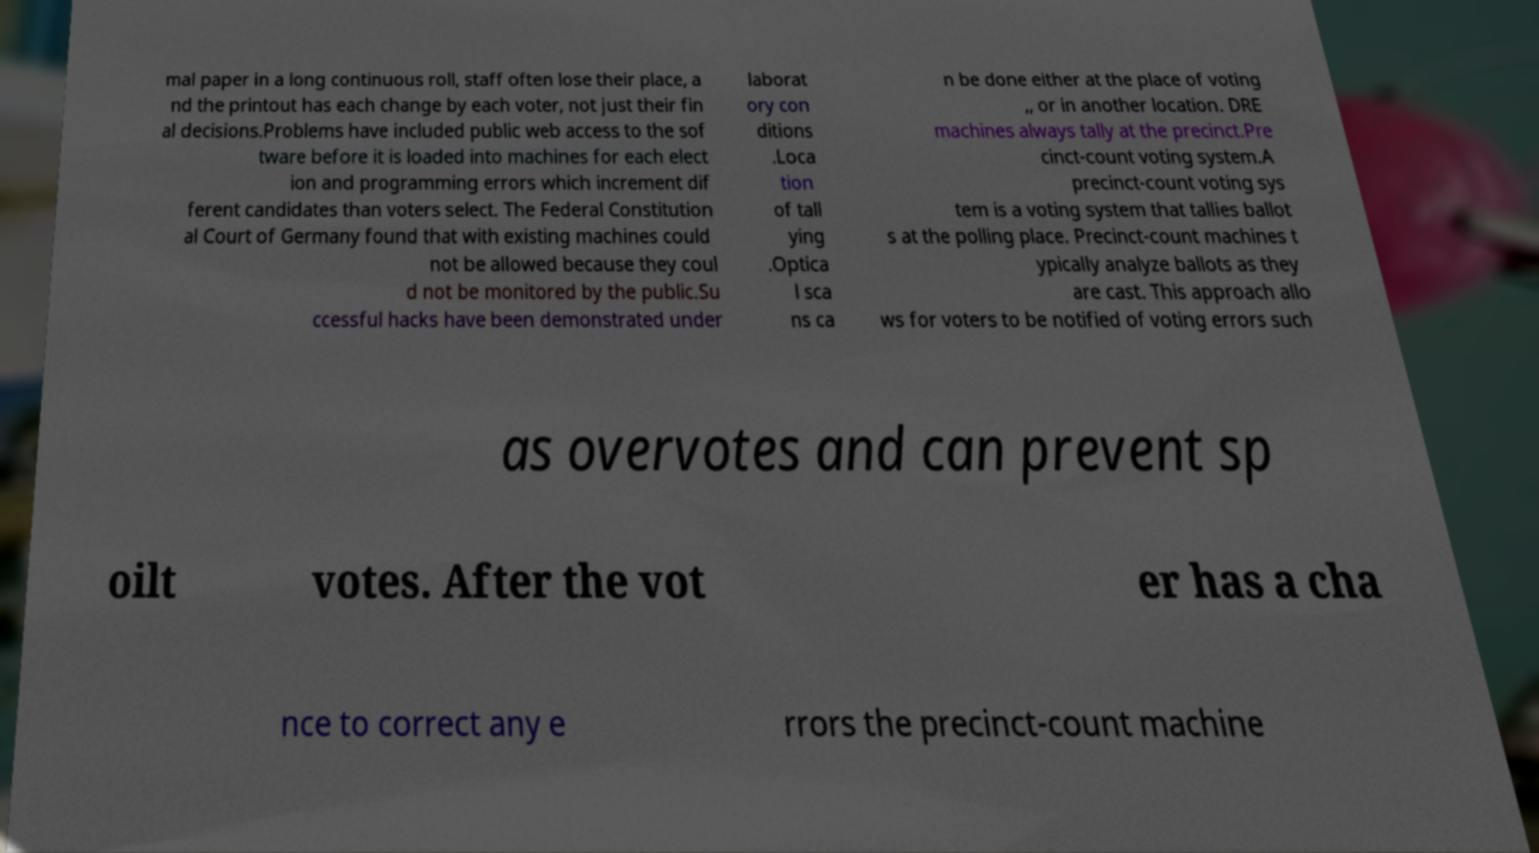Can you accurately transcribe the text from the provided image for me? mal paper in a long continuous roll, staff often lose their place, a nd the printout has each change by each voter, not just their fin al decisions.Problems have included public web access to the sof tware before it is loaded into machines for each elect ion and programming errors which increment dif ferent candidates than voters select. The Federal Constitution al Court of Germany found that with existing machines could not be allowed because they coul d not be monitored by the public.Su ccessful hacks have been demonstrated under laborat ory con ditions .Loca tion of tall ying .Optica l sca ns ca n be done either at the place of voting ,, or in another location. DRE machines always tally at the precinct.Pre cinct-count voting system.A precinct-count voting sys tem is a voting system that tallies ballot s at the polling place. Precinct-count machines t ypically analyze ballots as they are cast. This approach allo ws for voters to be notified of voting errors such as overvotes and can prevent sp oilt votes. After the vot er has a cha nce to correct any e rrors the precinct-count machine 